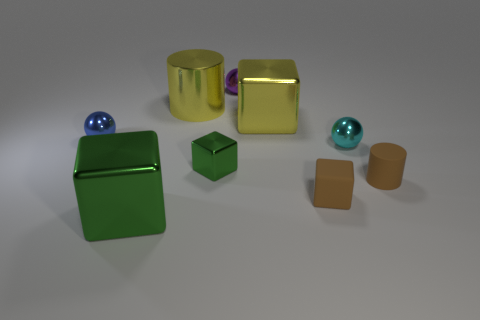How many balls are either cyan shiny things or matte objects?
Provide a succinct answer. 1. There is a green shiny block left of the green metal object behind the green cube in front of the brown matte block; how big is it?
Keep it short and to the point. Large. There is a brown block; are there any shiny blocks to the right of it?
Give a very brief answer. No. There is a tiny rubber object that is the same color as the rubber block; what shape is it?
Your answer should be compact. Cylinder. How many things are tiny matte objects behind the rubber block or tiny metallic things?
Ensure brevity in your answer.  5. There is a cyan ball that is made of the same material as the small green cube; what is its size?
Your response must be concise. Small. Do the metallic cylinder and the metal ball that is behind the large yellow metallic block have the same size?
Provide a succinct answer. No. What color is the large thing that is behind the tiny blue metallic ball and to the left of the small purple sphere?
Offer a terse response. Yellow. How many things are big blocks on the right side of the big yellow metallic cylinder or small green objects right of the small blue metallic ball?
Make the answer very short. 2. There is a big cylinder behind the green metallic thing left of the cylinder behind the tiny green shiny thing; what color is it?
Your response must be concise. Yellow. 